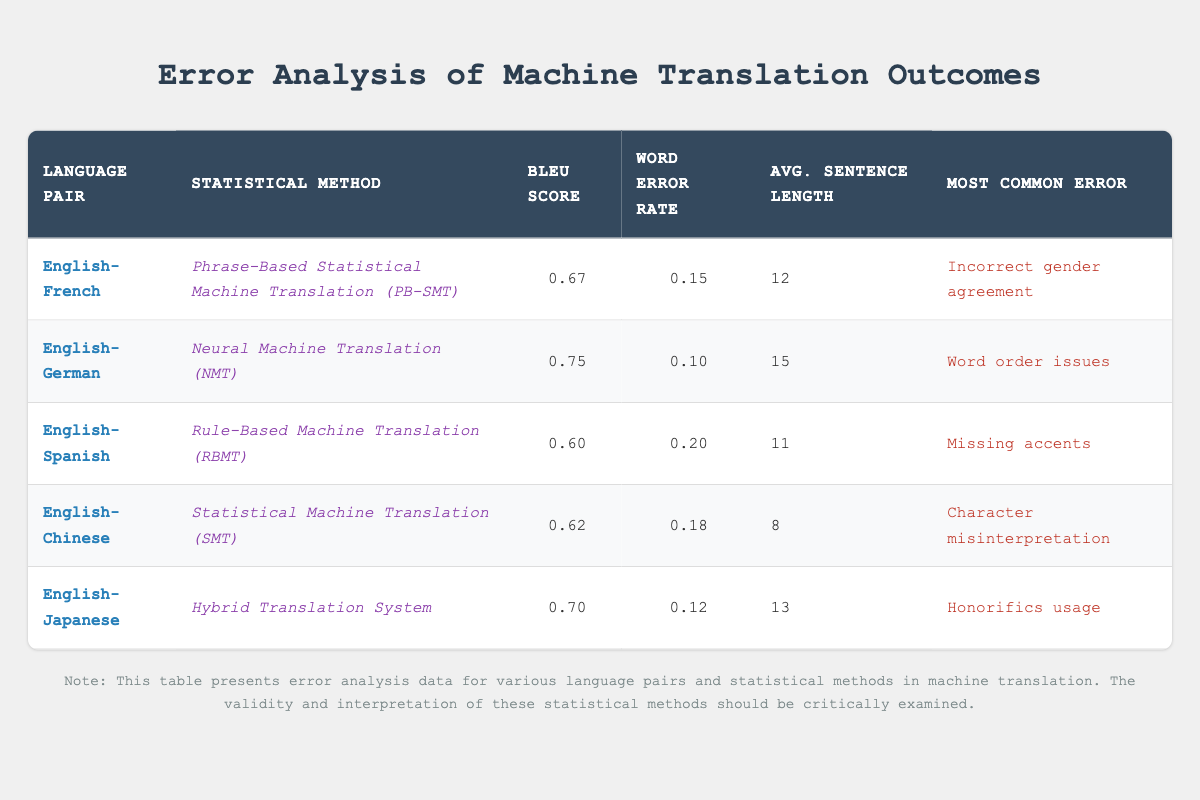What is the BLEU score for the English-German machine translation? The BLEU score is explicitly listed in the table for the English-German row. It shows a score of 0.75.
Answer: 0.75 What is the most common error encountered in English-Spanish translations? The table specifies that the most common error for English-Spanish is "Missing accents."
Answer: Missing accents Which statistical method has the lowest word error rate? By comparing the word error rates in the table, we find that the English-German translation using Neural Machine Translation has the lowest rate at 0.10.
Answer: Neural Machine Translation What is the average BLEU score for the statistical methods listed in the table? To find the average BLEU score, we sum the BLEU scores (0.67 + 0.75 + 0.60 + 0.62 + 0.70 = 3.34) and divide by the number of methods (5). The average BLEU score is 3.34 / 5 = 0.668.
Answer: 0.668 Is "Incorrect gender agreement" the most common error for any of the statistical methods? Yes, the data indicates that "Incorrect gender agreement" is the most common error for the English-French pair, so the answer is true.
Answer: Yes Which translation method, on average, has the longest sentence length? The table shows the average sentence lengths for each methods: English-German = 15, English-Japanese = 13, English-French = 12, English-Spanish = 11, English-Chinese = 8. The longest average sentence length is 15 for English-German.
Answer: English-German Is there a correlation between BLEU scores and most common errors listed? The table does not provide quantitative values for common errors, making it impossible to directly establish a correlation based on the available data. Therefore, the answer is no.
Answer: No What error was most frequently associated with the phrases in the hybrid translation system? The English-Japanese row in the table indicates that "Honorifics usage" is the most common error for the Hybrid Translation System.
Answer: Honorifics usage Which language pair has the highest average sentence length? By examining the average sentence lengths, English-German has the highest value at 15 sentences in length compared to the others.
Answer: English-German 